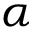Convert formula to latex. <formula><loc_0><loc_0><loc_500><loc_500>\alpha</formula> 